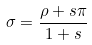Convert formula to latex. <formula><loc_0><loc_0><loc_500><loc_500>\sigma = \frac { \rho + s \pi } { 1 + s }</formula> 